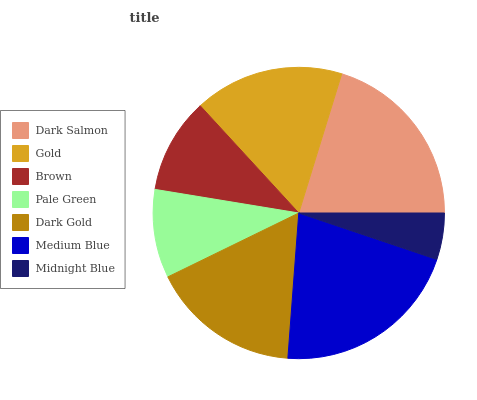Is Midnight Blue the minimum?
Answer yes or no. Yes. Is Medium Blue the maximum?
Answer yes or no. Yes. Is Gold the minimum?
Answer yes or no. No. Is Gold the maximum?
Answer yes or no. No. Is Dark Salmon greater than Gold?
Answer yes or no. Yes. Is Gold less than Dark Salmon?
Answer yes or no. Yes. Is Gold greater than Dark Salmon?
Answer yes or no. No. Is Dark Salmon less than Gold?
Answer yes or no. No. Is Dark Gold the high median?
Answer yes or no. Yes. Is Dark Gold the low median?
Answer yes or no. Yes. Is Medium Blue the high median?
Answer yes or no. No. Is Brown the low median?
Answer yes or no. No. 